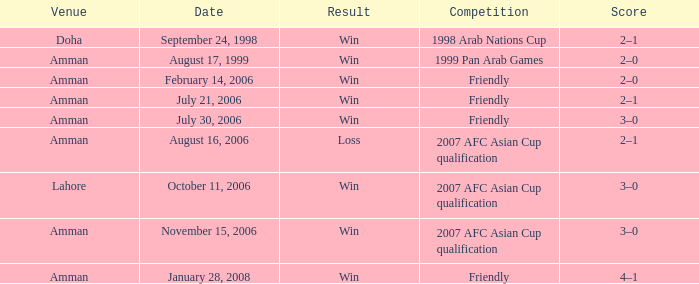Where did Ra'fat Ali play on August 17, 1999? Amman. 